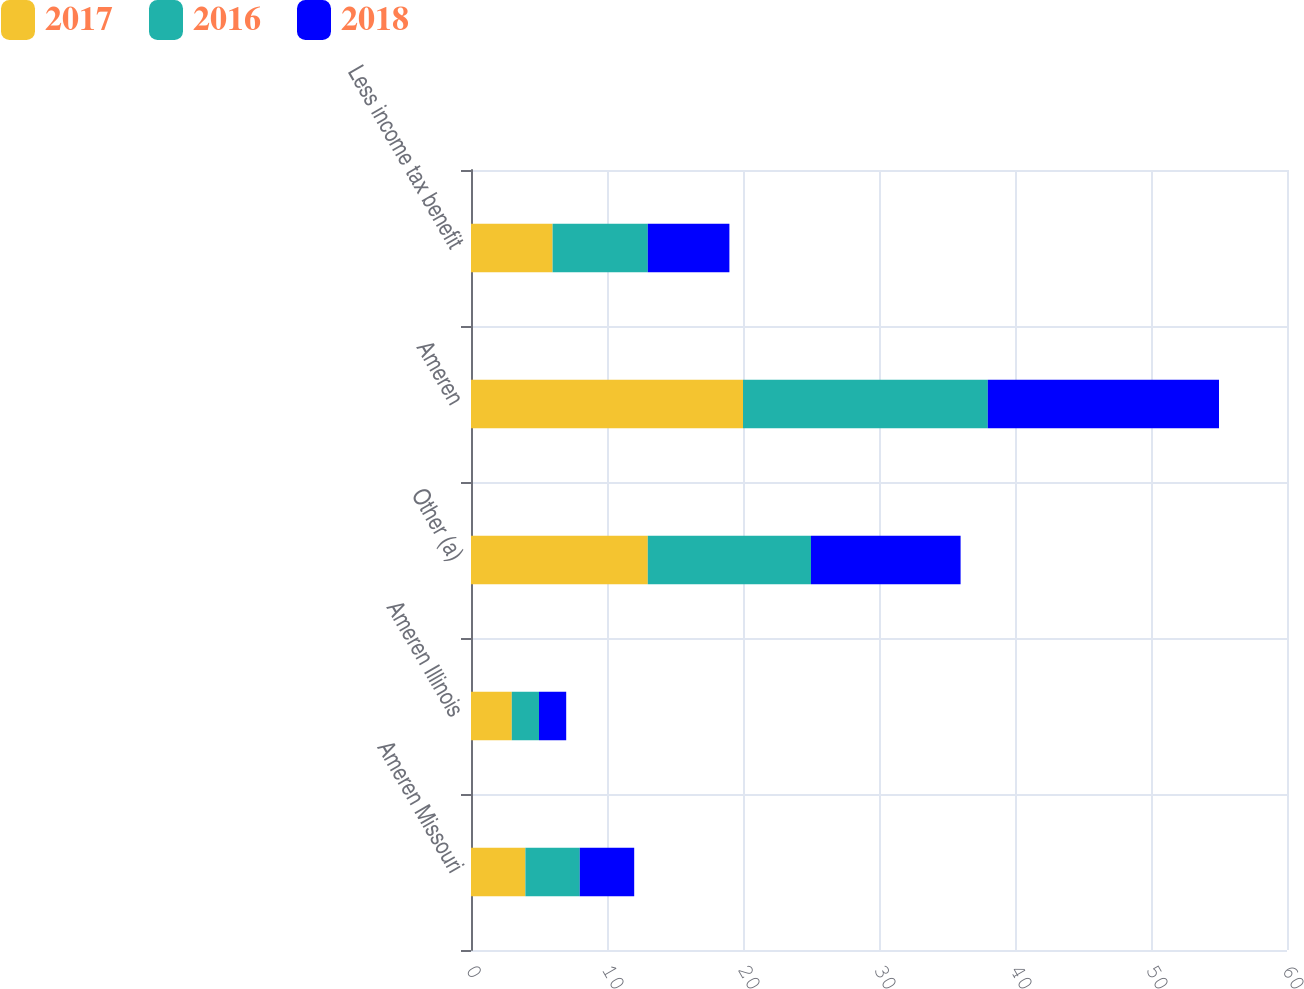<chart> <loc_0><loc_0><loc_500><loc_500><stacked_bar_chart><ecel><fcel>Ameren Missouri<fcel>Ameren Illinois<fcel>Other (a)<fcel>Ameren<fcel>Less income tax benefit<nl><fcel>2017<fcel>4<fcel>3<fcel>13<fcel>20<fcel>6<nl><fcel>2016<fcel>4<fcel>2<fcel>12<fcel>18<fcel>7<nl><fcel>2018<fcel>4<fcel>2<fcel>11<fcel>17<fcel>6<nl></chart> 